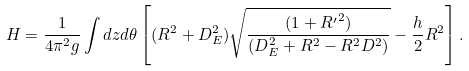Convert formula to latex. <formula><loc_0><loc_0><loc_500><loc_500>H = \frac { 1 } { 4 \pi ^ { 2 } g } \int d z d \theta \left [ ( R ^ { 2 } + D ^ { 2 } _ { E } ) \sqrt { \frac { ( 1 + { R ^ { \prime } } ^ { 2 } ) } { ( D ^ { 2 } _ { E } + R ^ { 2 } - R ^ { 2 } D ^ { 2 } ) } } - \frac { h } { 2 } R ^ { 2 } \right ] .</formula> 